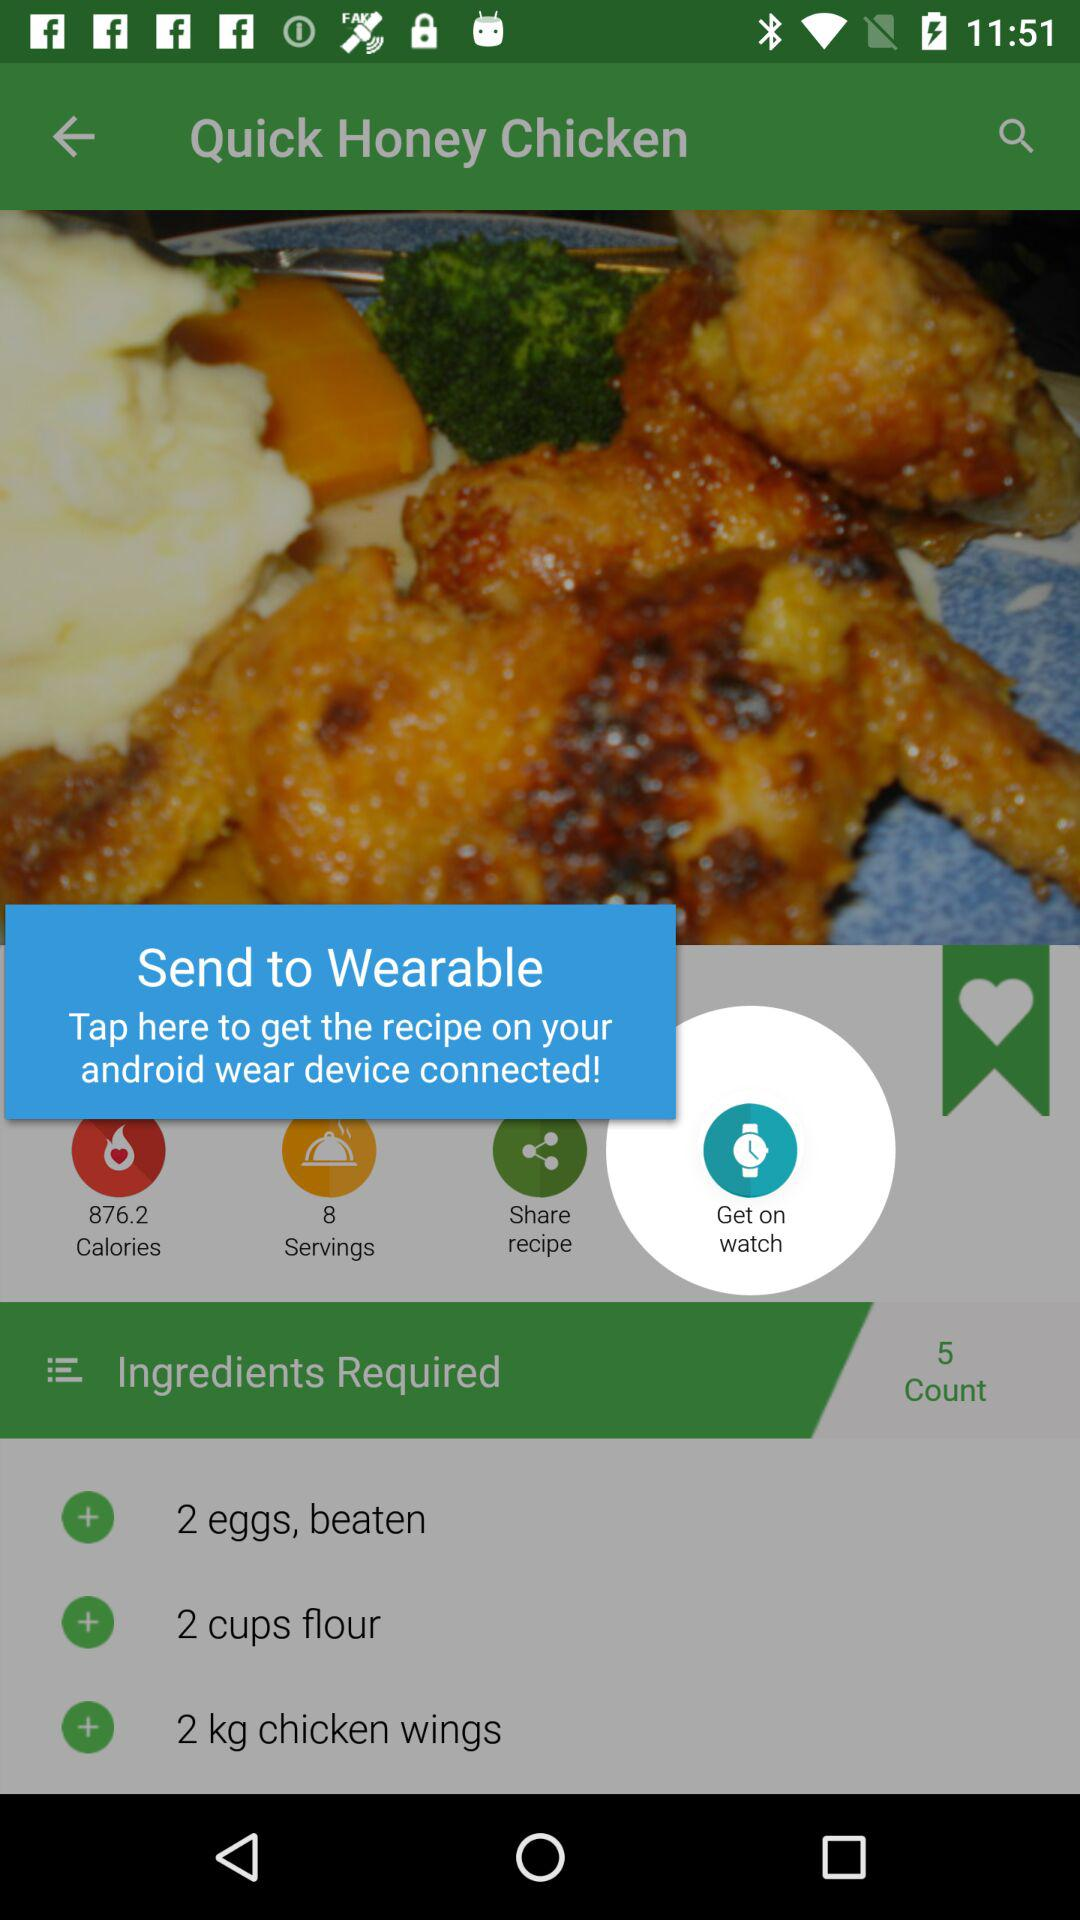How many servings does this recipe make?
Answer the question using a single word or phrase. 8 